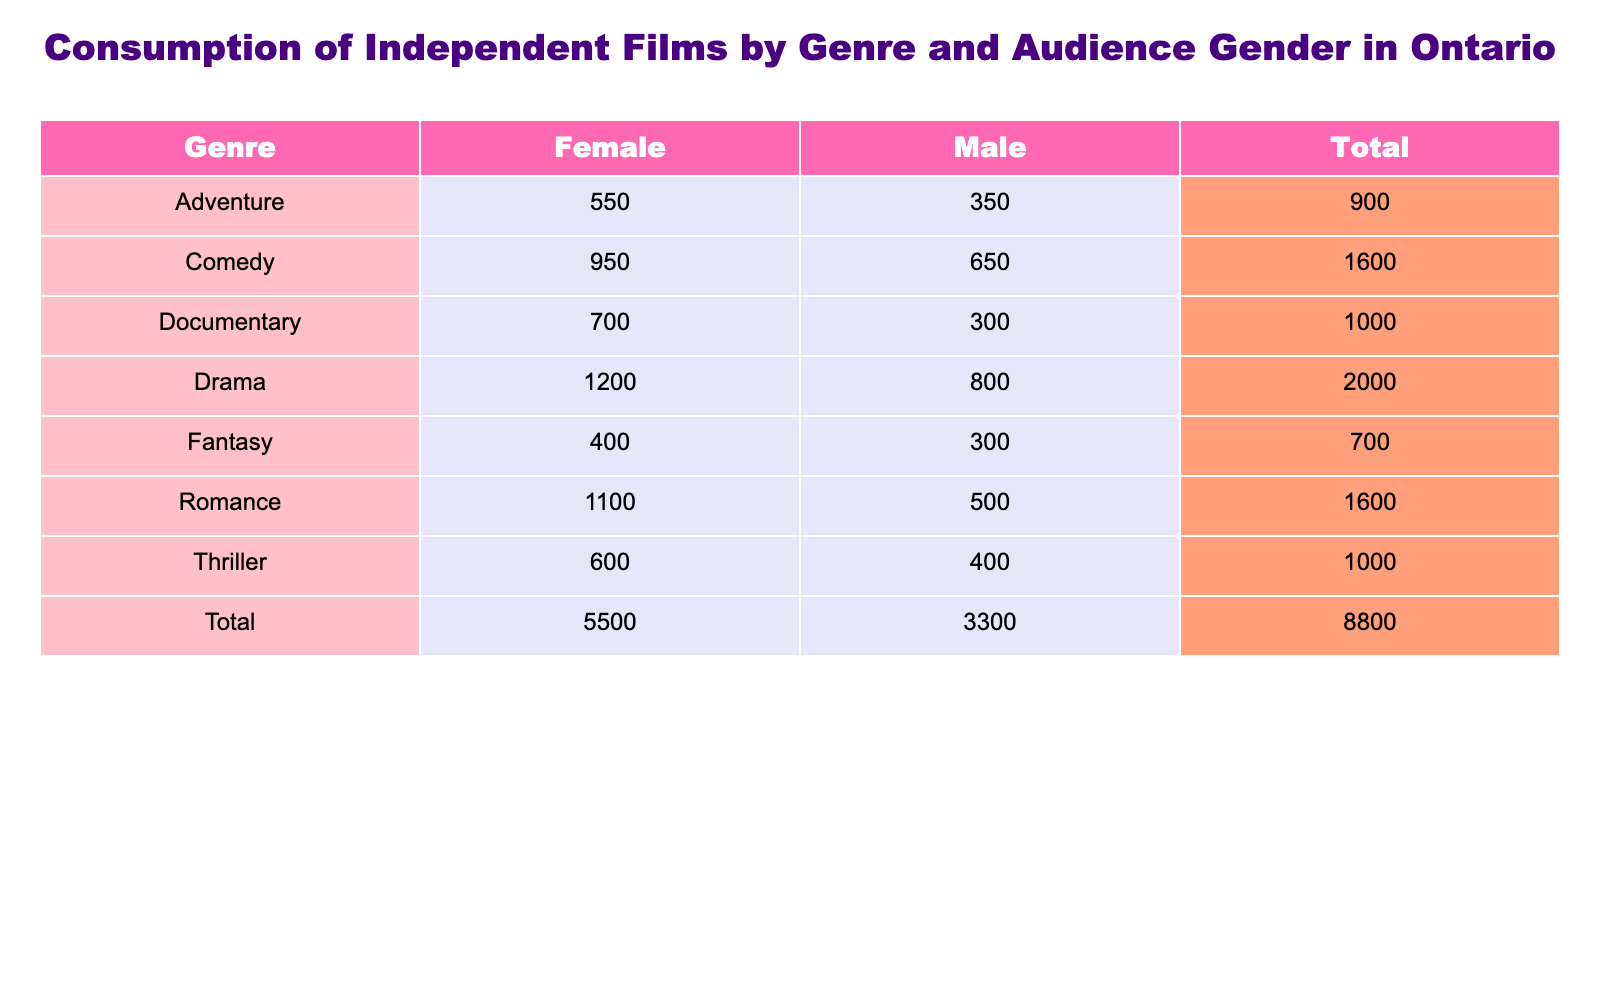What is the total number of viewers for romantic films? To find the total viewers for romantic films, I look at the "Romance" row and sum the viewers for both genders: 1100 (Female) + 500 (Male) = 1600.
Answer: 1600 Which genre has the highest number of male viewers? I will check the male viewers for each genre: Drama (800), Comedy (650), Romance (500), Thriller (400), Documentary (300), Fantasy (300), and Adventure (350). The highest is 800 for Drama.
Answer: Drama How many more female viewers watched dramas compared to thrillers? I will compare the female viewers for both genres: Drama has 1200 female viewers, while Thriller has 600. The difference is 1200 - 600 = 600.
Answer: 600 Do more females than males prefer documentaries? Checking the documentary viewers: Female viewers are 700 and Male viewers are 300. Since 700 is greater than 300, the statement is true.
Answer: Yes What is the total number of viewers across all genres for male audiences? To find the total male viewers, I will sum the numbers for each male genre: 800 (Drama) + 650 (Comedy) + 500 (Romance) + 400 (Thriller) + 300 (Documentary) + 300 (Fantasy) + 350 (Adventure) = 3250.
Answer: 3250 Which genre has the lowest total number of viewers overall? I will analyze the total viewers for each genre: Drama (2000), Comedy (1600), Romance (1600), Thriller (1000), Documentary (1000), Fantasy (700), and Adventure (900). The lowest is 700 for Fantasy.
Answer: Fantasy What is the average number of female viewers across all genres? The total number of female viewers is: 1200 (Drama) + 950 (Comedy) + 1100 (Romance) + 600 (Thriller) + 700 (Documentary) + 400 (Fantasy) + 550 (Adventure) = 4550. There are 7 genres, so the average is 4550 / 7 ≈ 650.
Answer: 650 Are the total viewers for comedies greater than the total viewers for thrillers? The total for Comedy is: 950 (Female) + 650 (Male) = 1600. The total for Thriller is: 600 (Female) + 400 (Male) = 1000. Since 1600 is greater than 1000, the answer is yes.
Answer: Yes What percentage of total viewers for adventure films are female? First, I find total viewers for Adventure: 550 (Female) + 350 (Male) = 900. Then, I calculate the percentage of female viewers: (550 / 900) * 100 ≈ 61.11%.
Answer: 61.11% 